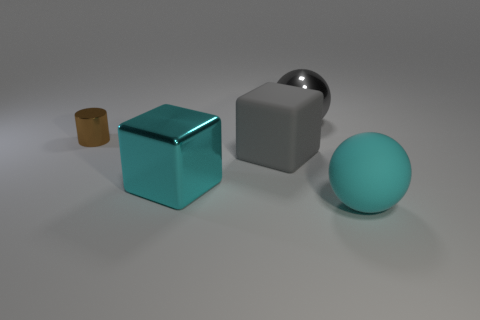What is the color of the metallic ball?
Your response must be concise. Gray. Is the number of gray metallic balls on the right side of the small object greater than the number of brown cylinders that are to the right of the big cyan rubber object?
Keep it short and to the point. Yes. There is a thing that is right of the gray metallic object; what color is it?
Give a very brief answer. Cyan. There is a ball behind the small metallic thing; is its size the same as the gray thing that is in front of the small brown cylinder?
Offer a terse response. Yes. How many objects are tiny yellow balls or metallic cubes?
Give a very brief answer. 1. There is a cyan thing that is to the left of the large gray object that is behind the gray matte cube; what is its material?
Keep it short and to the point. Metal. What number of other big cyan metal things have the same shape as the cyan metallic thing?
Your answer should be compact. 0. Is there a big metal thing that has the same color as the large metal cube?
Ensure brevity in your answer.  No. How many things are either big gray shiny spheres behind the brown thing or shiny objects that are behind the large matte block?
Your response must be concise. 2. There is a cyan cube that is in front of the small brown cylinder; is there a thing that is right of it?
Give a very brief answer. Yes. 